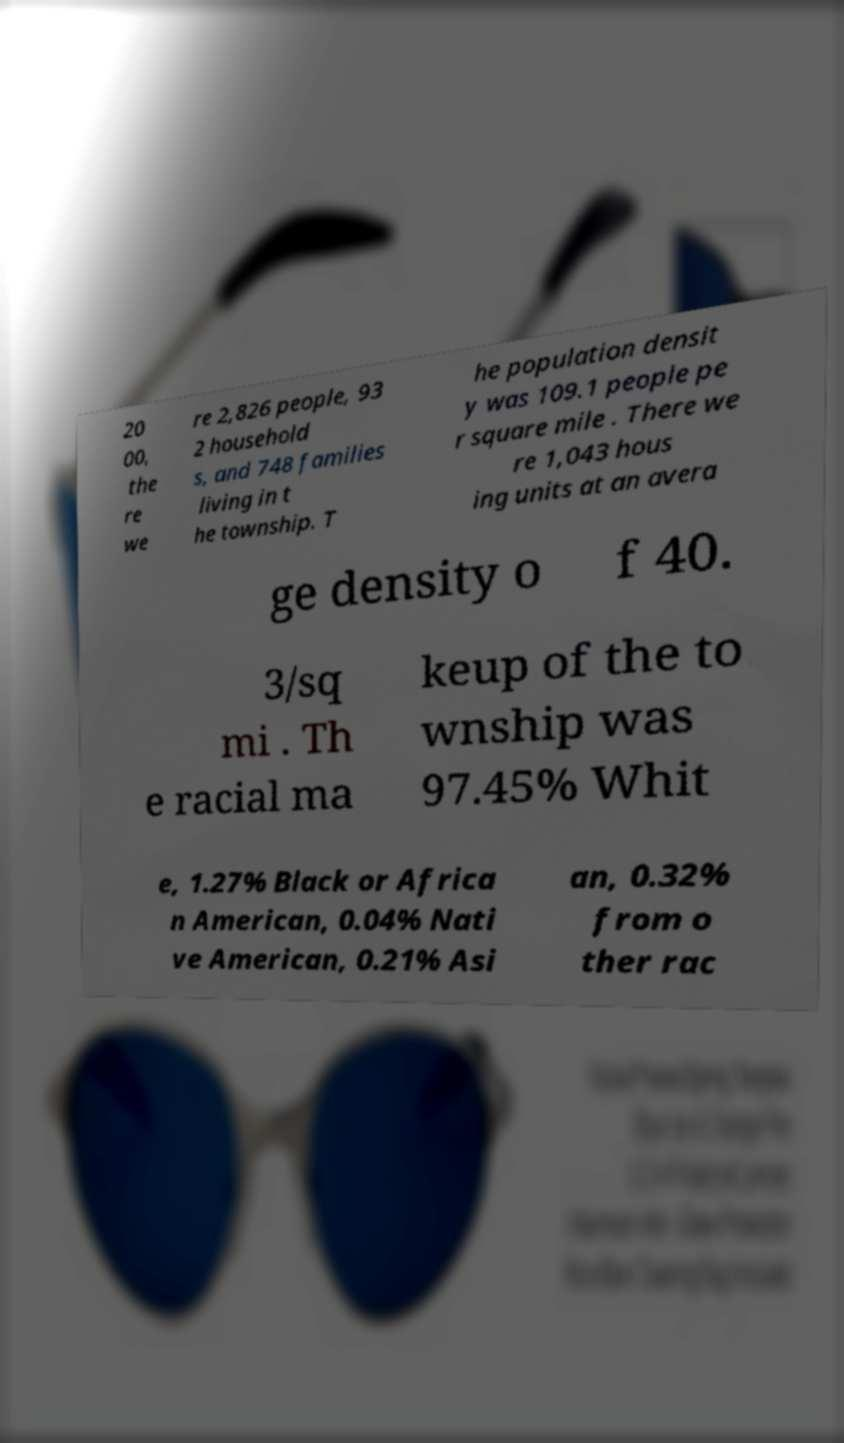Can you read and provide the text displayed in the image?This photo seems to have some interesting text. Can you extract and type it out for me? 20 00, the re we re 2,826 people, 93 2 household s, and 748 families living in t he township. T he population densit y was 109.1 people pe r square mile . There we re 1,043 hous ing units at an avera ge density o f 40. 3/sq mi . Th e racial ma keup of the to wnship was 97.45% Whit e, 1.27% Black or Africa n American, 0.04% Nati ve American, 0.21% Asi an, 0.32% from o ther rac 